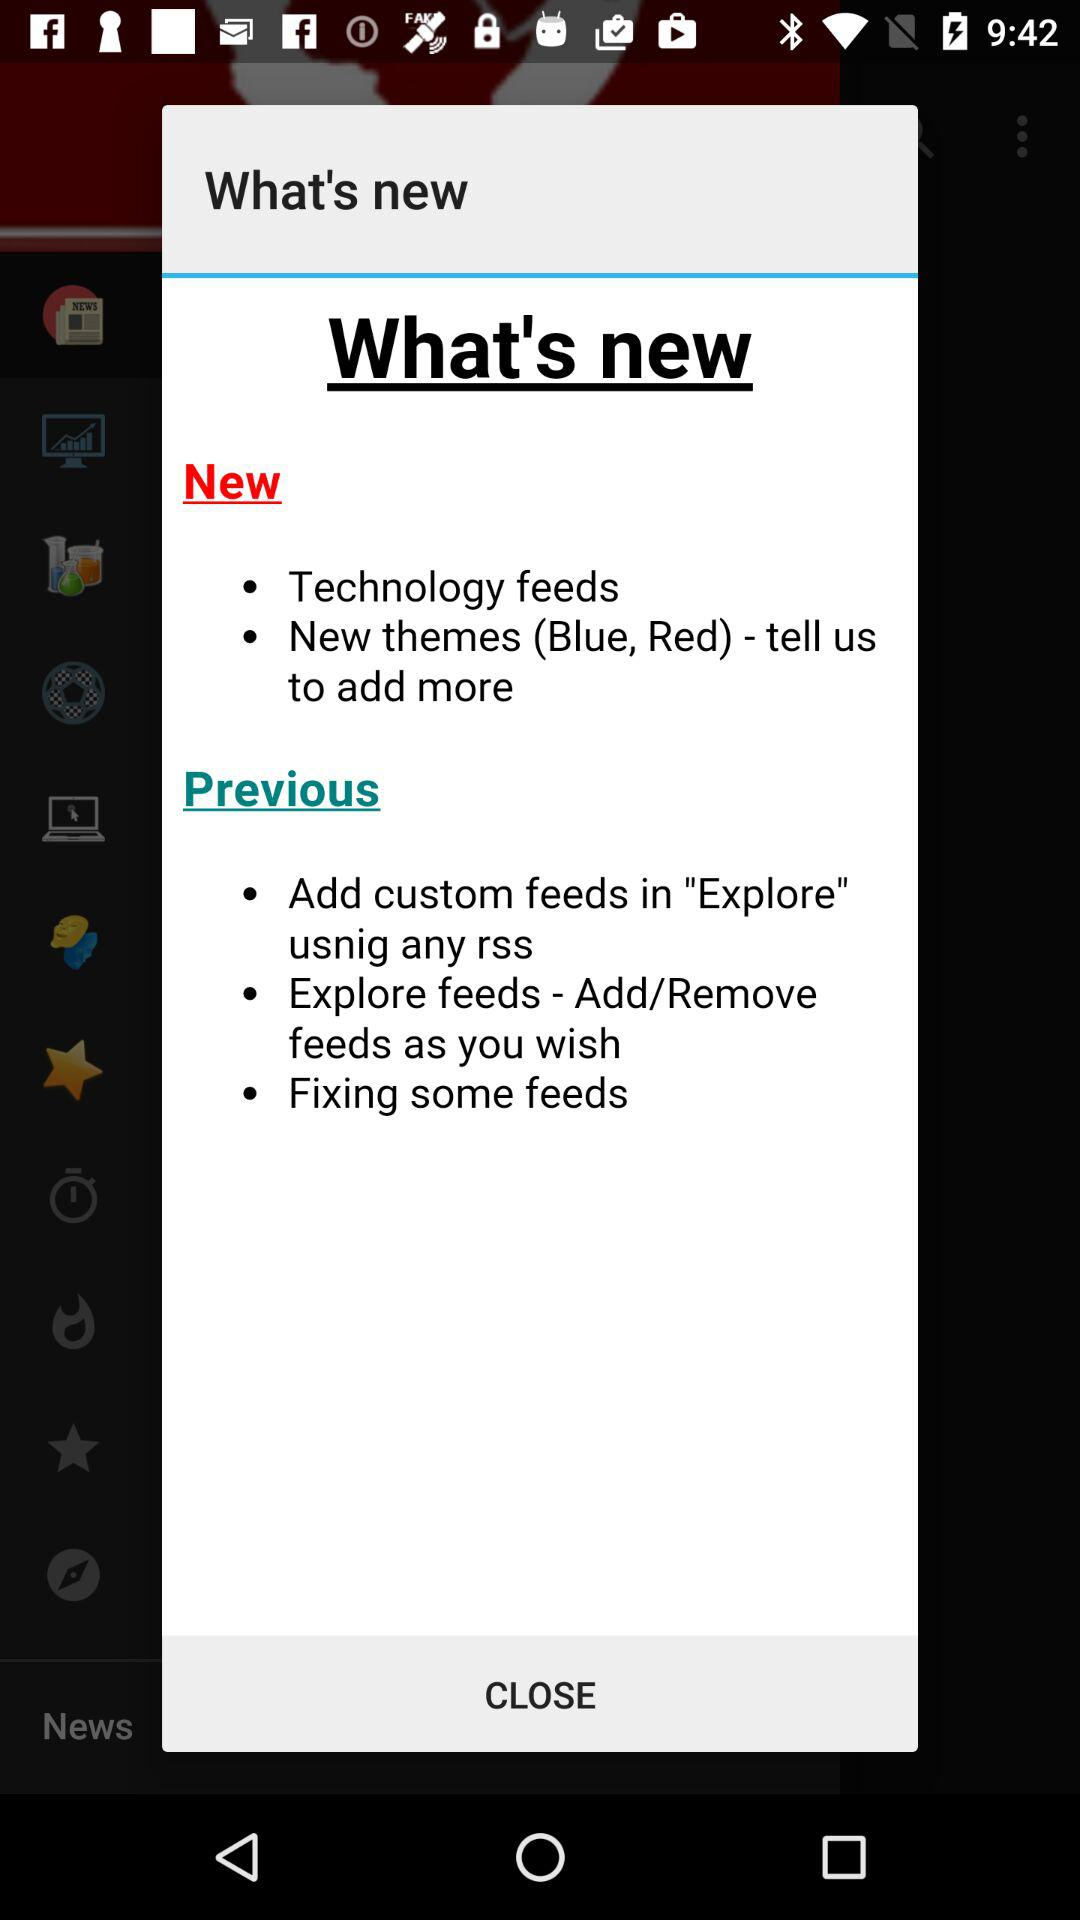How many new themes are there?
Answer the question using a single word or phrase. 2 